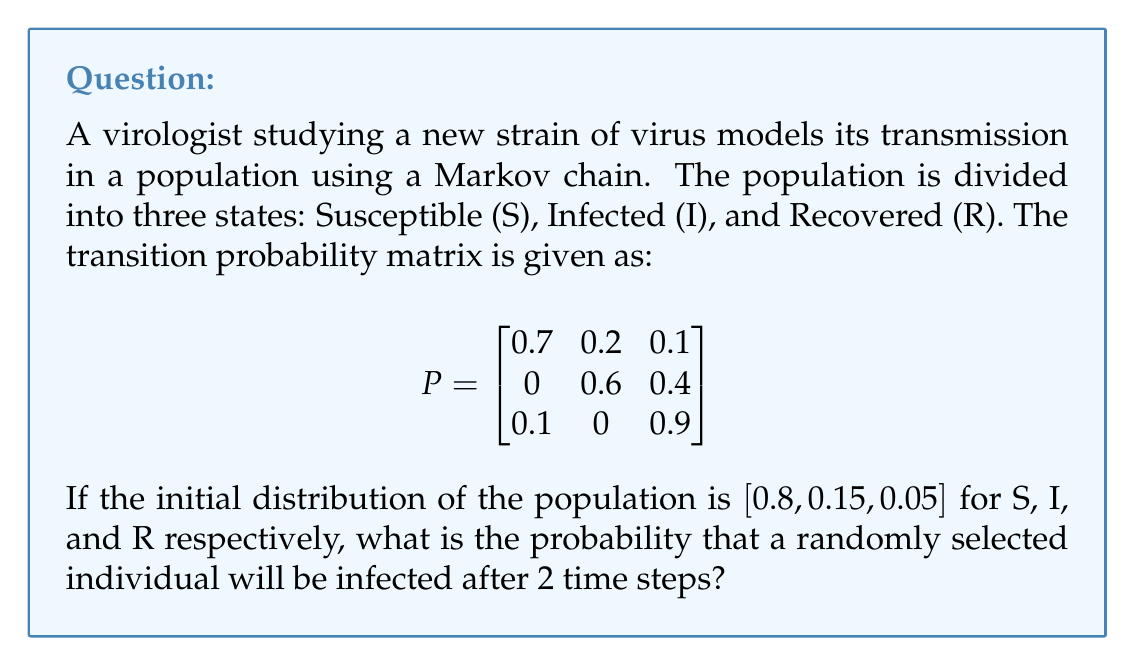Give your solution to this math problem. To solve this problem, we need to use the properties of Markov chains and matrix multiplication. Let's break it down step-by-step:

1) Let $\pi_0 = [0.8, 0.15, 0.05]$ be the initial distribution vector.

2) To find the distribution after 2 time steps, we need to multiply $\pi_0$ by $P^2$ (the transition matrix squared).

3) First, let's calculate $P^2$:

   $$P^2 = P \times P = \begin{bmatrix}
   0.7 & 0.2 & 0.1 \\
   0 & 0.6 & 0.4 \\
   0.1 & 0 & 0.9
   \end{bmatrix} \times \begin{bmatrix}
   0.7 & 0.2 & 0.1 \\
   0 & 0.6 & 0.4 \\
   0.1 & 0 & 0.9
   \end{bmatrix}$$

   $$P^2 = \begin{bmatrix}
   0.51 & 0.26 & 0.23 \\
   0.04 & 0.36 & 0.60 \\
   0.16 & 0.18 & 0.66
   \end{bmatrix}$$

4) Now, we multiply $\pi_0$ by $P^2$:

   $$\pi_2 = \pi_0 \times P^2 = [0.8, 0.15, 0.05] \times \begin{bmatrix}
   0.51 & 0.26 & 0.23 \\
   0.04 & 0.36 & 0.60 \\
   0.16 & 0.18 & 0.66
   \end{bmatrix}$$

5) Performing the matrix multiplication:

   $$\pi_2 = [0.418, 0.274, 0.308]$$

6) The probability of being infected after 2 time steps is the second element of $\pi_2$, which is 0.274.
Answer: 0.274 